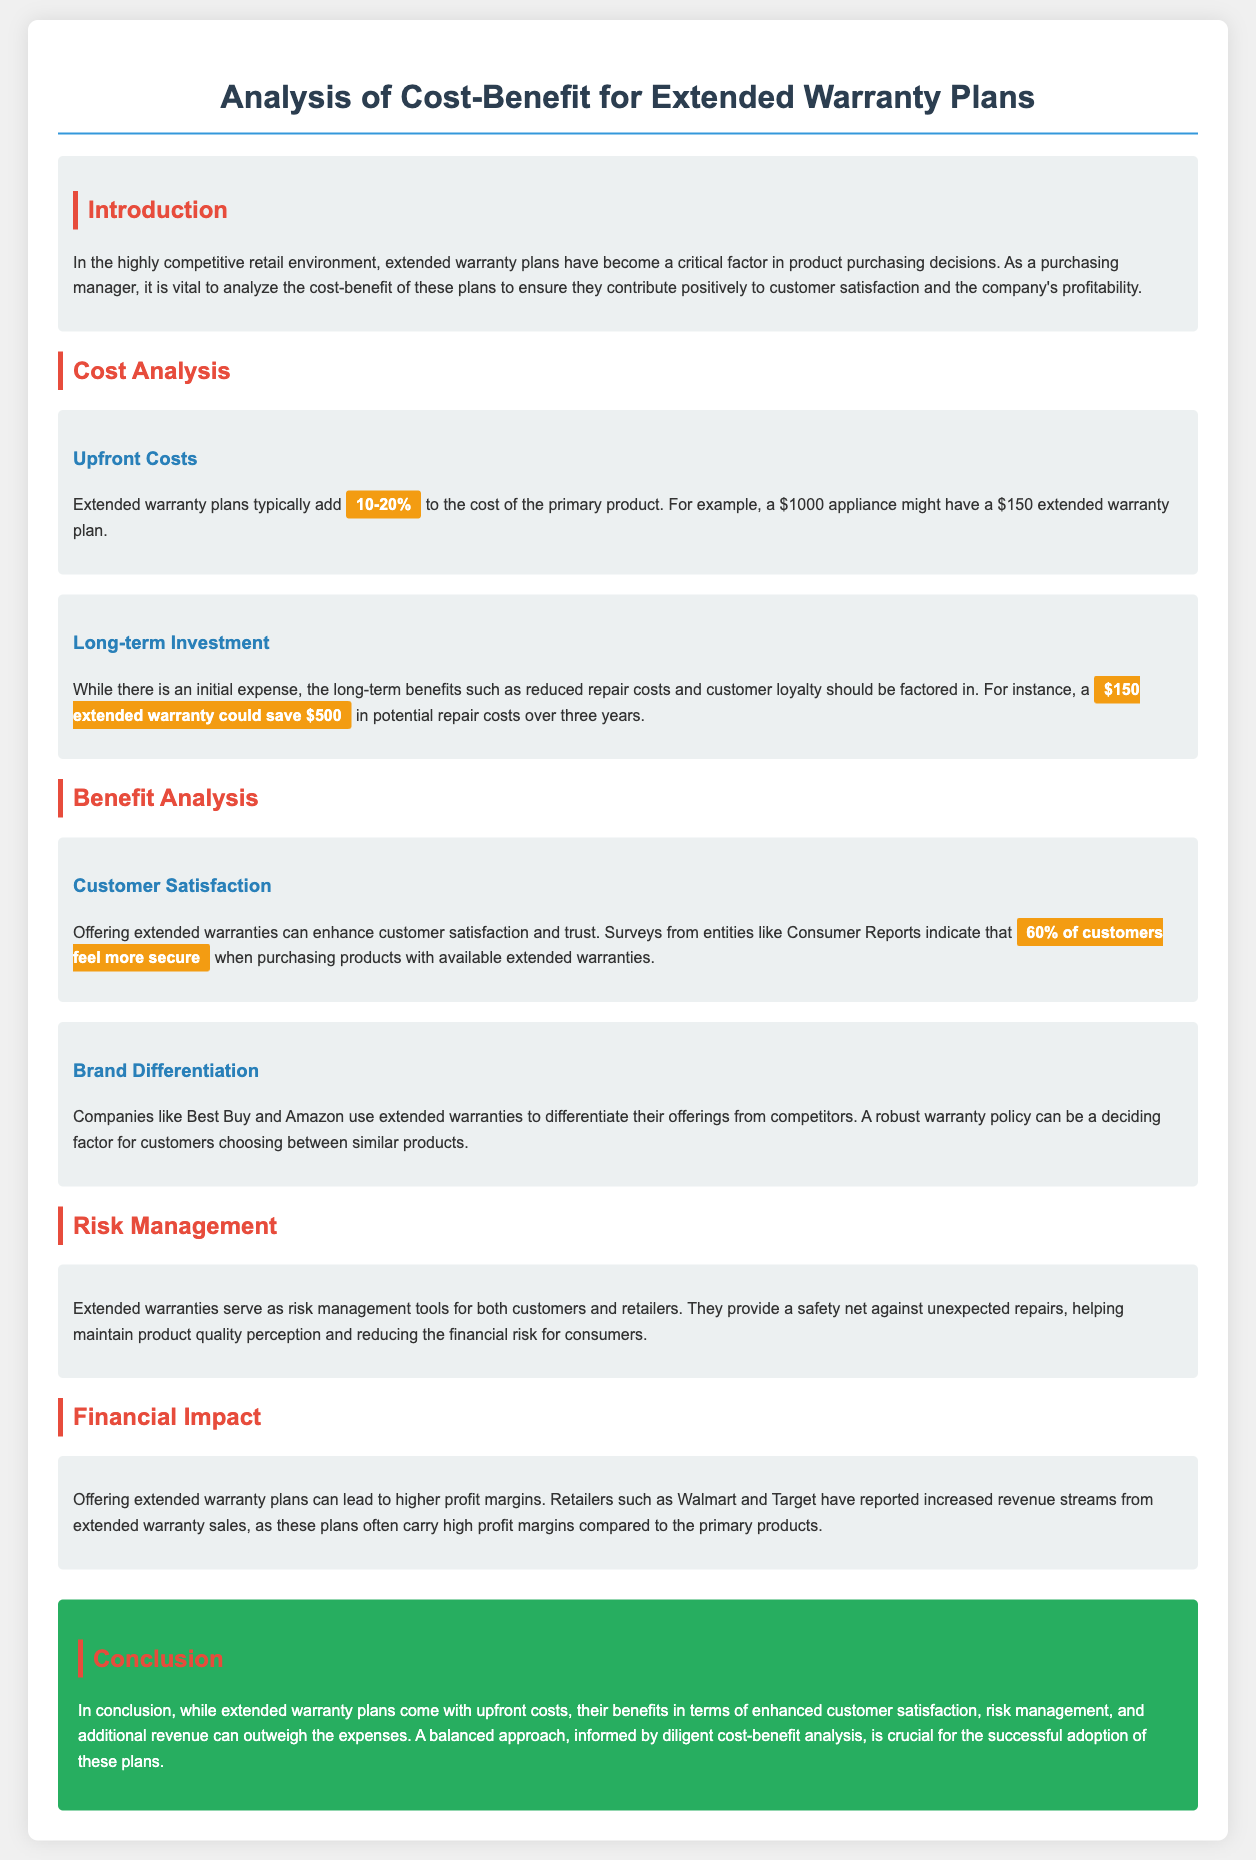What percentage do extended warranty plans typically add to the cost of the primary product? The document states that extended warranty plans typically add 10-20% to the cost of the primary product.
Answer: 10-20% How much can a $150 extended warranty save in potential repair costs over three years? The document mentions that a $150 extended warranty could save $500 in potential repair costs over three years.
Answer: $500 What percentage of customers feel more secure with extended warranties? According to the document, 60% of customers feel more secure when purchasing products with available extended warranties.
Answer: 60% What is a key benefit of offering extended warranties mentioned in the document? The document highlights enhanced customer satisfaction as a key benefit of offering extended warranties.
Answer: Enhanced customer satisfaction Which retailers are mentioned as reporting increased revenue from extended warranty sales? Walmart and Target are cited in the document as retailers that have reported increased revenue streams from extended warranty sales.
Answer: Walmart and Target How do extended warranties serve as risk management tools? The document indicates that extended warranties provide a safety net against unexpected repairs, thus helping maintain product quality perception and reducing financial risk for consumers.
Answer: Safety net against unexpected repairs What critical factor is stressed for the successful adoption of extended warranty plans? The document stresses the importance of a balanced approach informed by diligent cost-benefit analysis for the successful adoption of extended warranty plans.
Answer: Diligent cost-benefit analysis Which companies are mentioned as using extended warranties to differentiate their offerings? The document specifically mentions Best Buy and Amazon as companies that use extended warranties for differentiation.
Answer: Best Buy and Amazon 